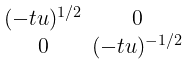<formula> <loc_0><loc_0><loc_500><loc_500>\begin{smallmatrix} ( - t u ) ^ { 1 / 2 } & 0 \\ 0 & ( - t u ) ^ { - 1 / 2 } \end{smallmatrix}</formula> 